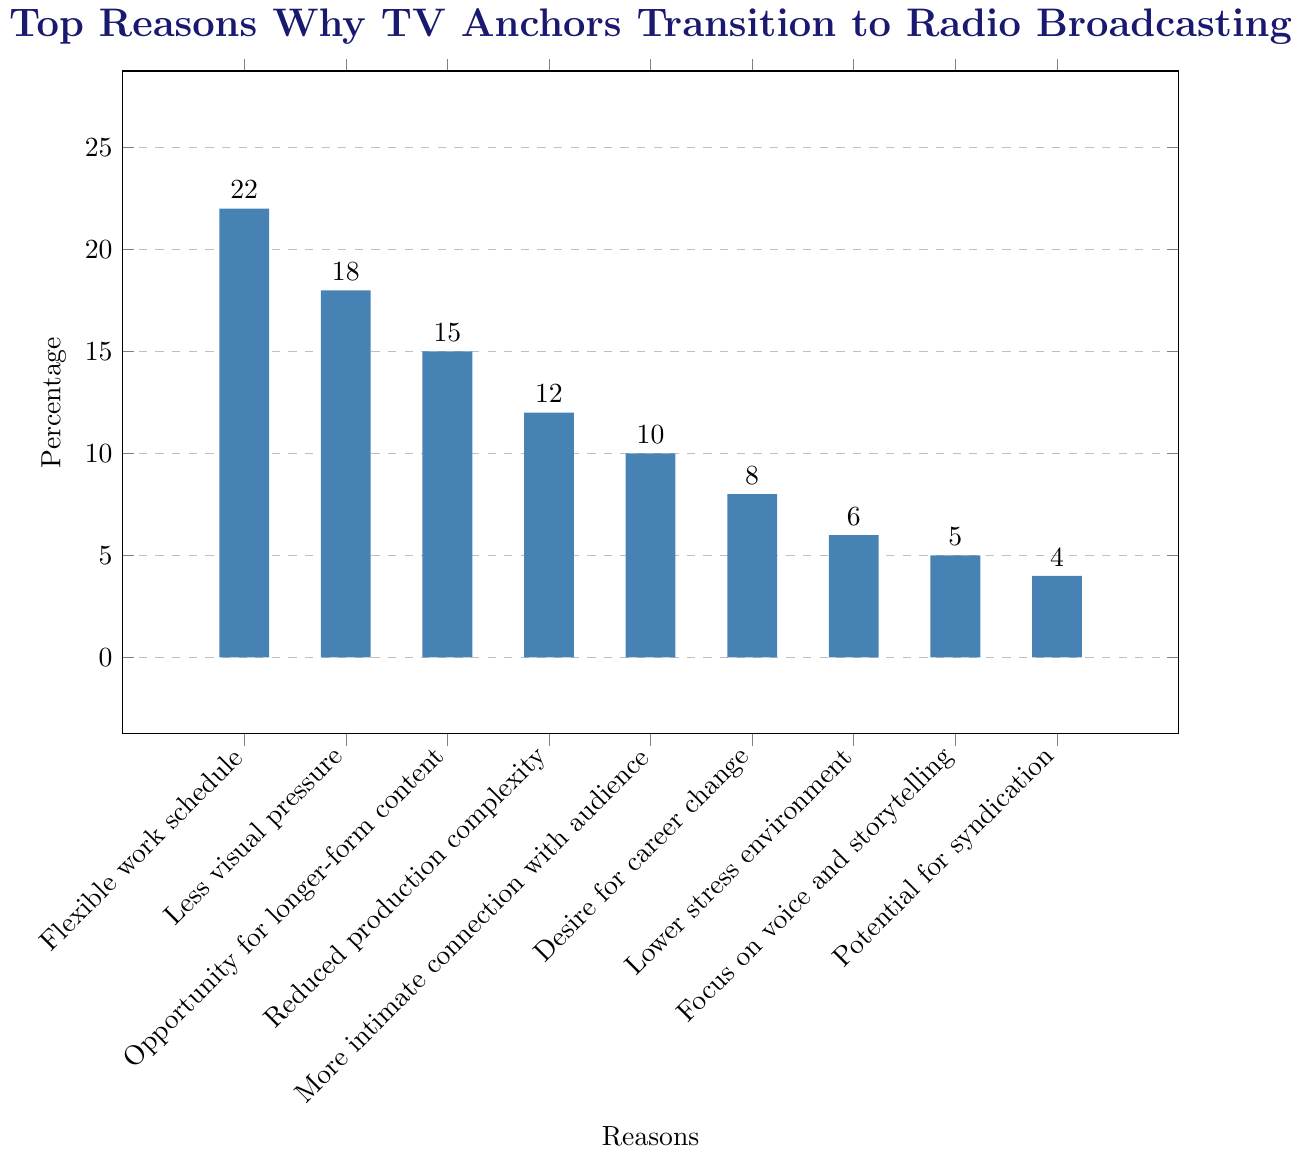Which reason has the highest percentage? First, identify the bar with the greatest height. This bar represents "Flexible work schedule" with a percentage of 22.
Answer: Flexible work schedule Which reason has the lowest percentage? Observe the shortest bar, which corresponds to "Potential for syndication" with a percentage of 4.
Answer: Potential for syndication How much higher is the percentage for "Flexible work schedule" compared to "Lower stress environment"? The percentage for "Flexible work schedule" is 22. The percentage for "Lower stress environment" is 6. The difference is 22 - 6 = 16.
Answer: 16 What is the combined percentage of "Less visual pressure" and "Opportunity for longer-form content"? The percentages are 18 and 15, respectively. Summing these gives 18 + 15 = 33.
Answer: 33 Is the percentage for "Reduced production complexity" greater than or less than that for "More intimate connection with audience"? Compare the percentages: 12 for "Reduced production complexity" and 10 for "More intimate connection with audience". 12 is greater than 10.
Answer: Greater How many reasons have a percentage of 10 or higher? Visual inspection reveals that the bars for "Flexible work schedule", "Less visual pressure", "Opportunity for longer-form content", "Reduced production complexity", "More intimate connection with audience", and "Desire for career change" all have percentages of 10 or higher. There are 6 such reasons.
Answer: 6 What is the median percentage value among all the reasons? Arrange the percentages in ascending order: 4, 5, 6, 8, 10, 12, 15, 18, 22. The median is the middle value, which is 10.
Answer: 10 Which reasons have percentages greater than 10 but less than 20? Identify bars with heights falling between 10 and 20. These are "Less visual pressure" (18), "Opportunity for longer-form content" (15), and "Reduced production complexity" (12).
Answer: Less visual pressure; Opportunity for longer-form content; Reduced production complexity 